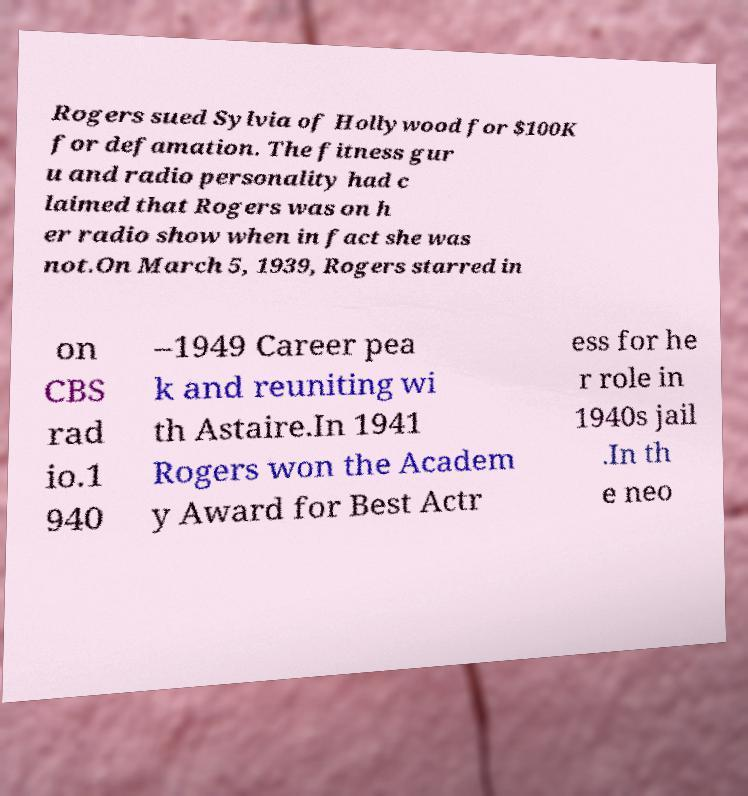What messages or text are displayed in this image? I need them in a readable, typed format. Rogers sued Sylvia of Hollywood for $100K for defamation. The fitness gur u and radio personality had c laimed that Rogers was on h er radio show when in fact she was not.On March 5, 1939, Rogers starred in on CBS rad io.1 940 –1949 Career pea k and reuniting wi th Astaire.In 1941 Rogers won the Academ y Award for Best Actr ess for he r role in 1940s jail .In th e neo 